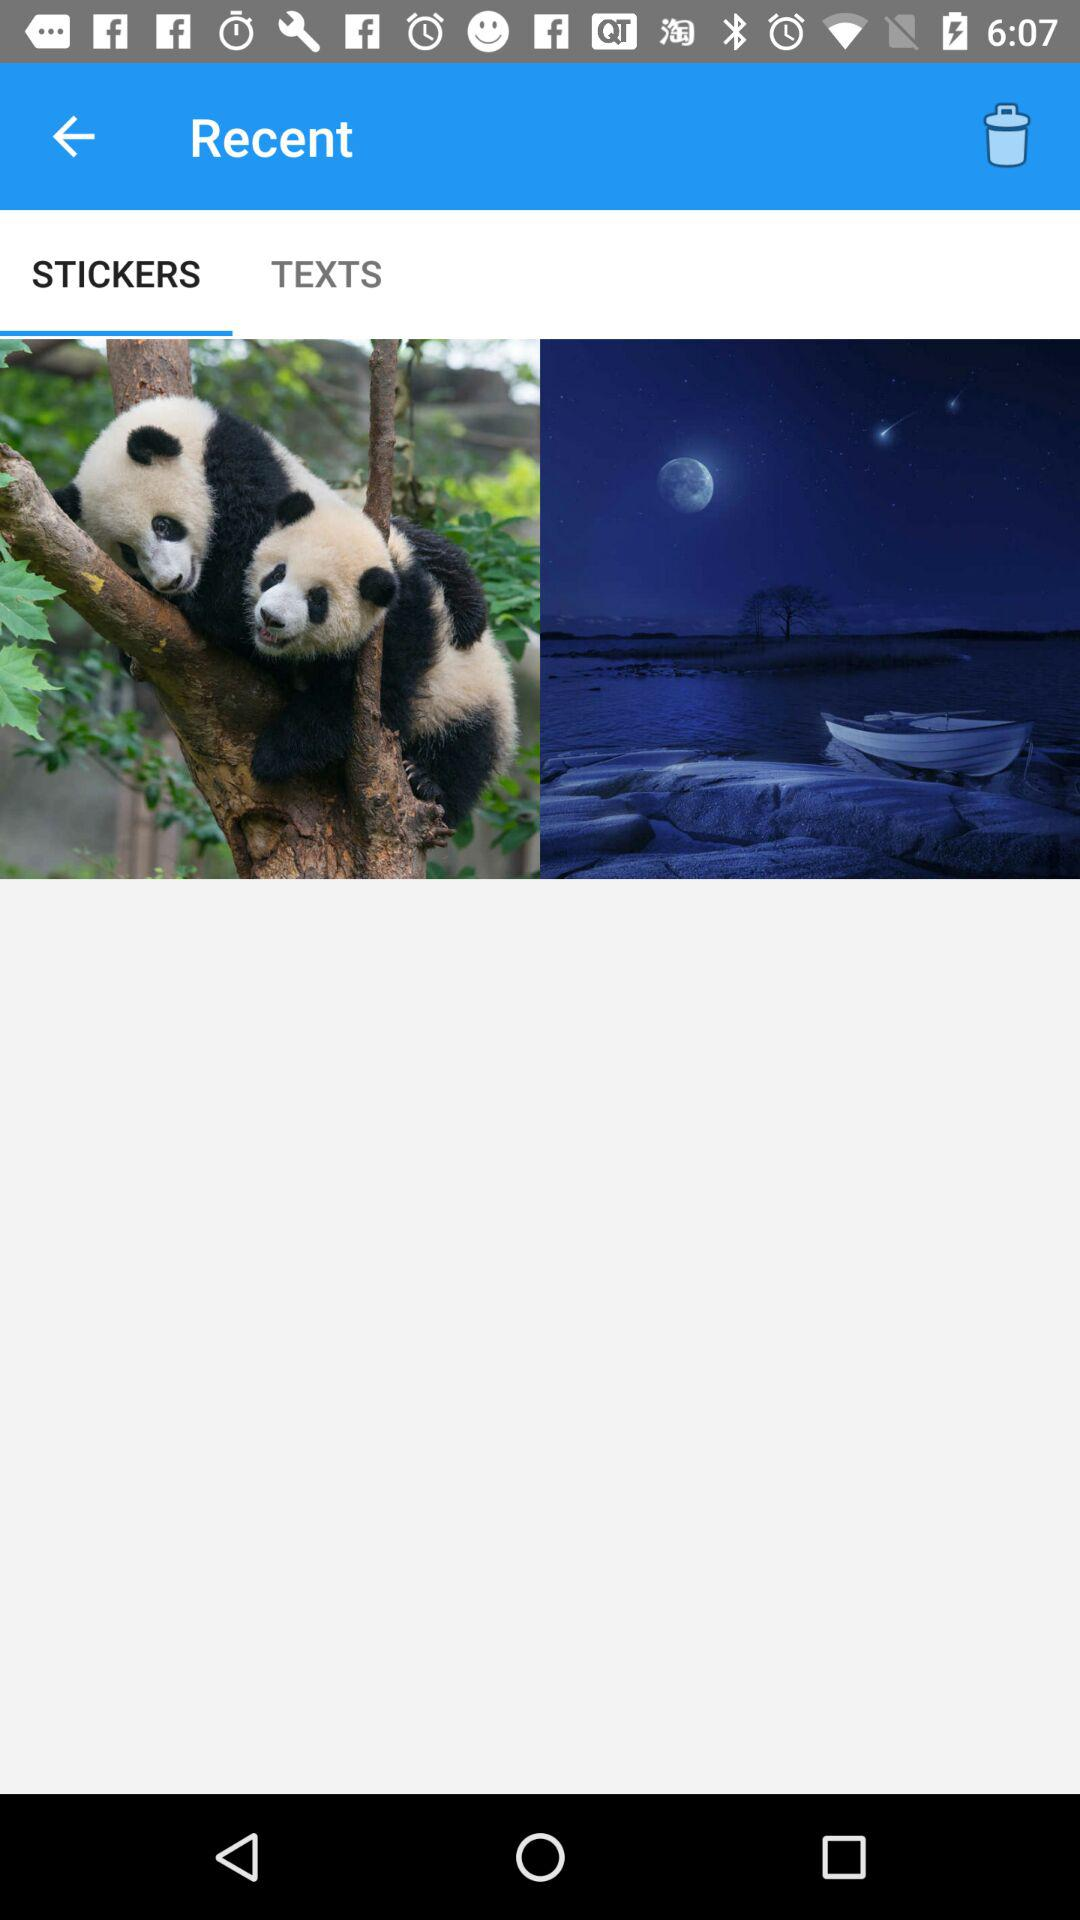How many more panda bears are there than boats?
Answer the question using a single word or phrase. 1 